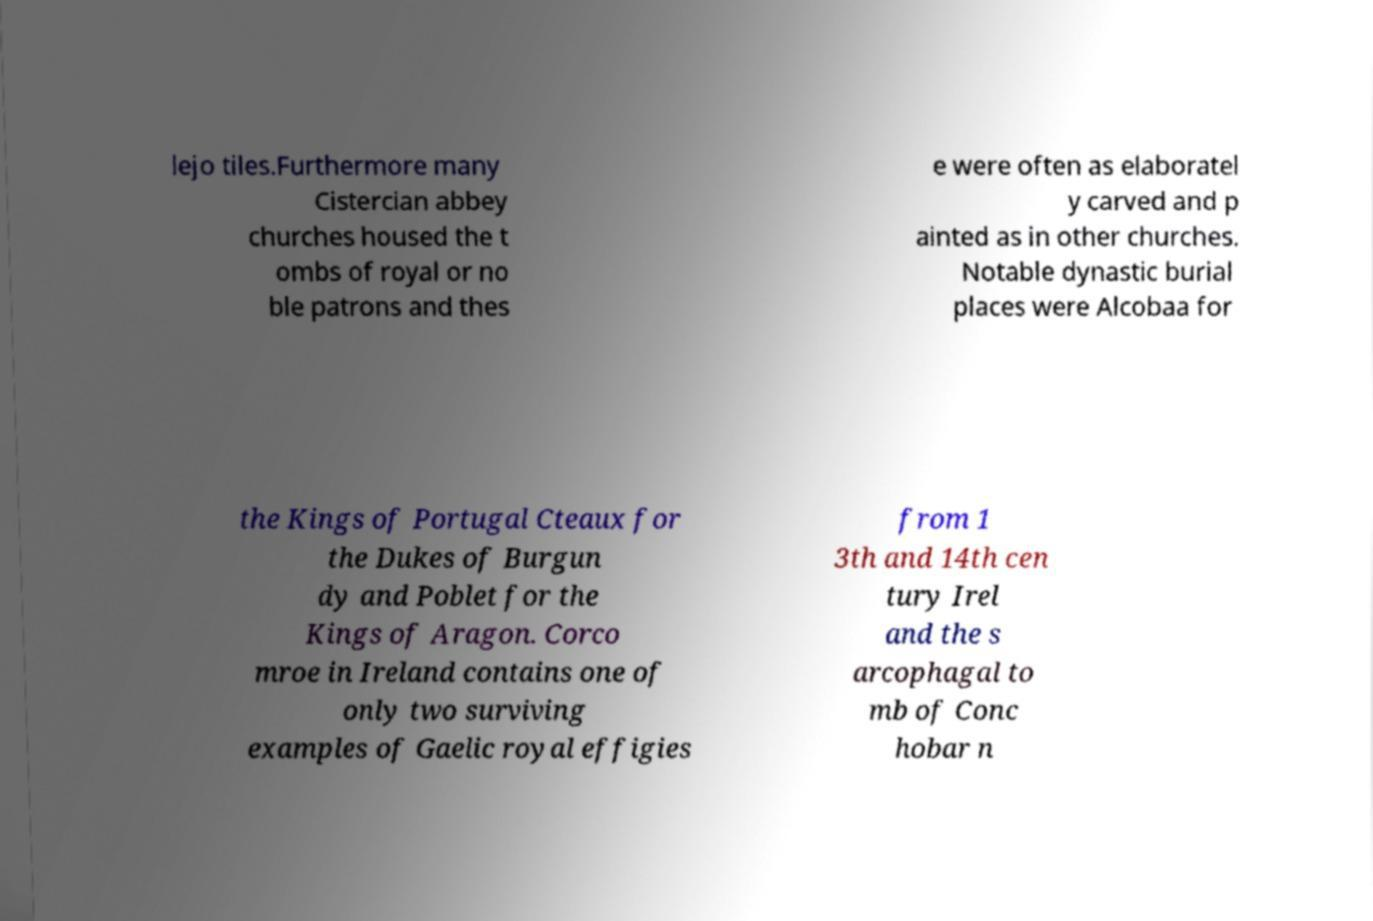There's text embedded in this image that I need extracted. Can you transcribe it verbatim? lejo tiles.Furthermore many Cistercian abbey churches housed the t ombs of royal or no ble patrons and thes e were often as elaboratel y carved and p ainted as in other churches. Notable dynastic burial places were Alcobaa for the Kings of Portugal Cteaux for the Dukes of Burgun dy and Poblet for the Kings of Aragon. Corco mroe in Ireland contains one of only two surviving examples of Gaelic royal effigies from 1 3th and 14th cen tury Irel and the s arcophagal to mb of Conc hobar n 